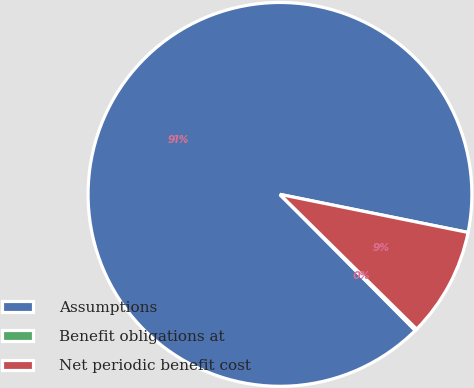Convert chart. <chart><loc_0><loc_0><loc_500><loc_500><pie_chart><fcel>Assumptions<fcel>Benefit obligations at<fcel>Net periodic benefit cost<nl><fcel>90.64%<fcel>0.16%<fcel>9.21%<nl></chart> 